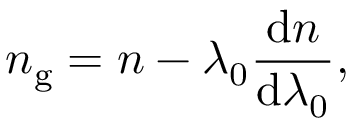Convert formula to latex. <formula><loc_0><loc_0><loc_500><loc_500>n _ { g } = n - \lambda _ { 0 } { \frac { d n } { d \lambda _ { 0 } } } ,</formula> 